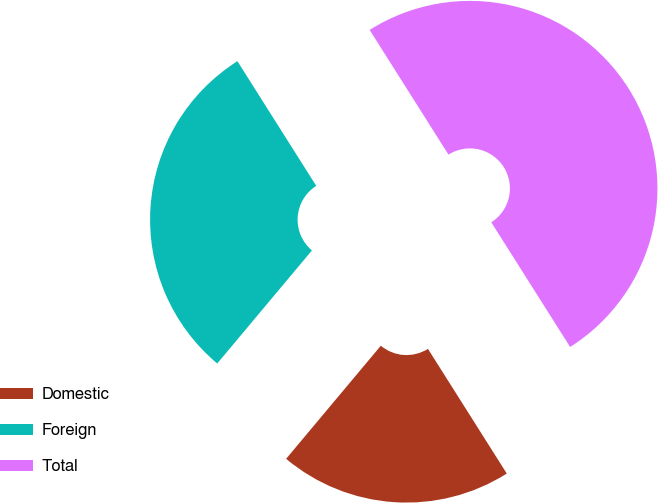Convert chart. <chart><loc_0><loc_0><loc_500><loc_500><pie_chart><fcel>Domestic<fcel>Foreign<fcel>Total<nl><fcel>20.07%<fcel>29.93%<fcel>50.0%<nl></chart> 